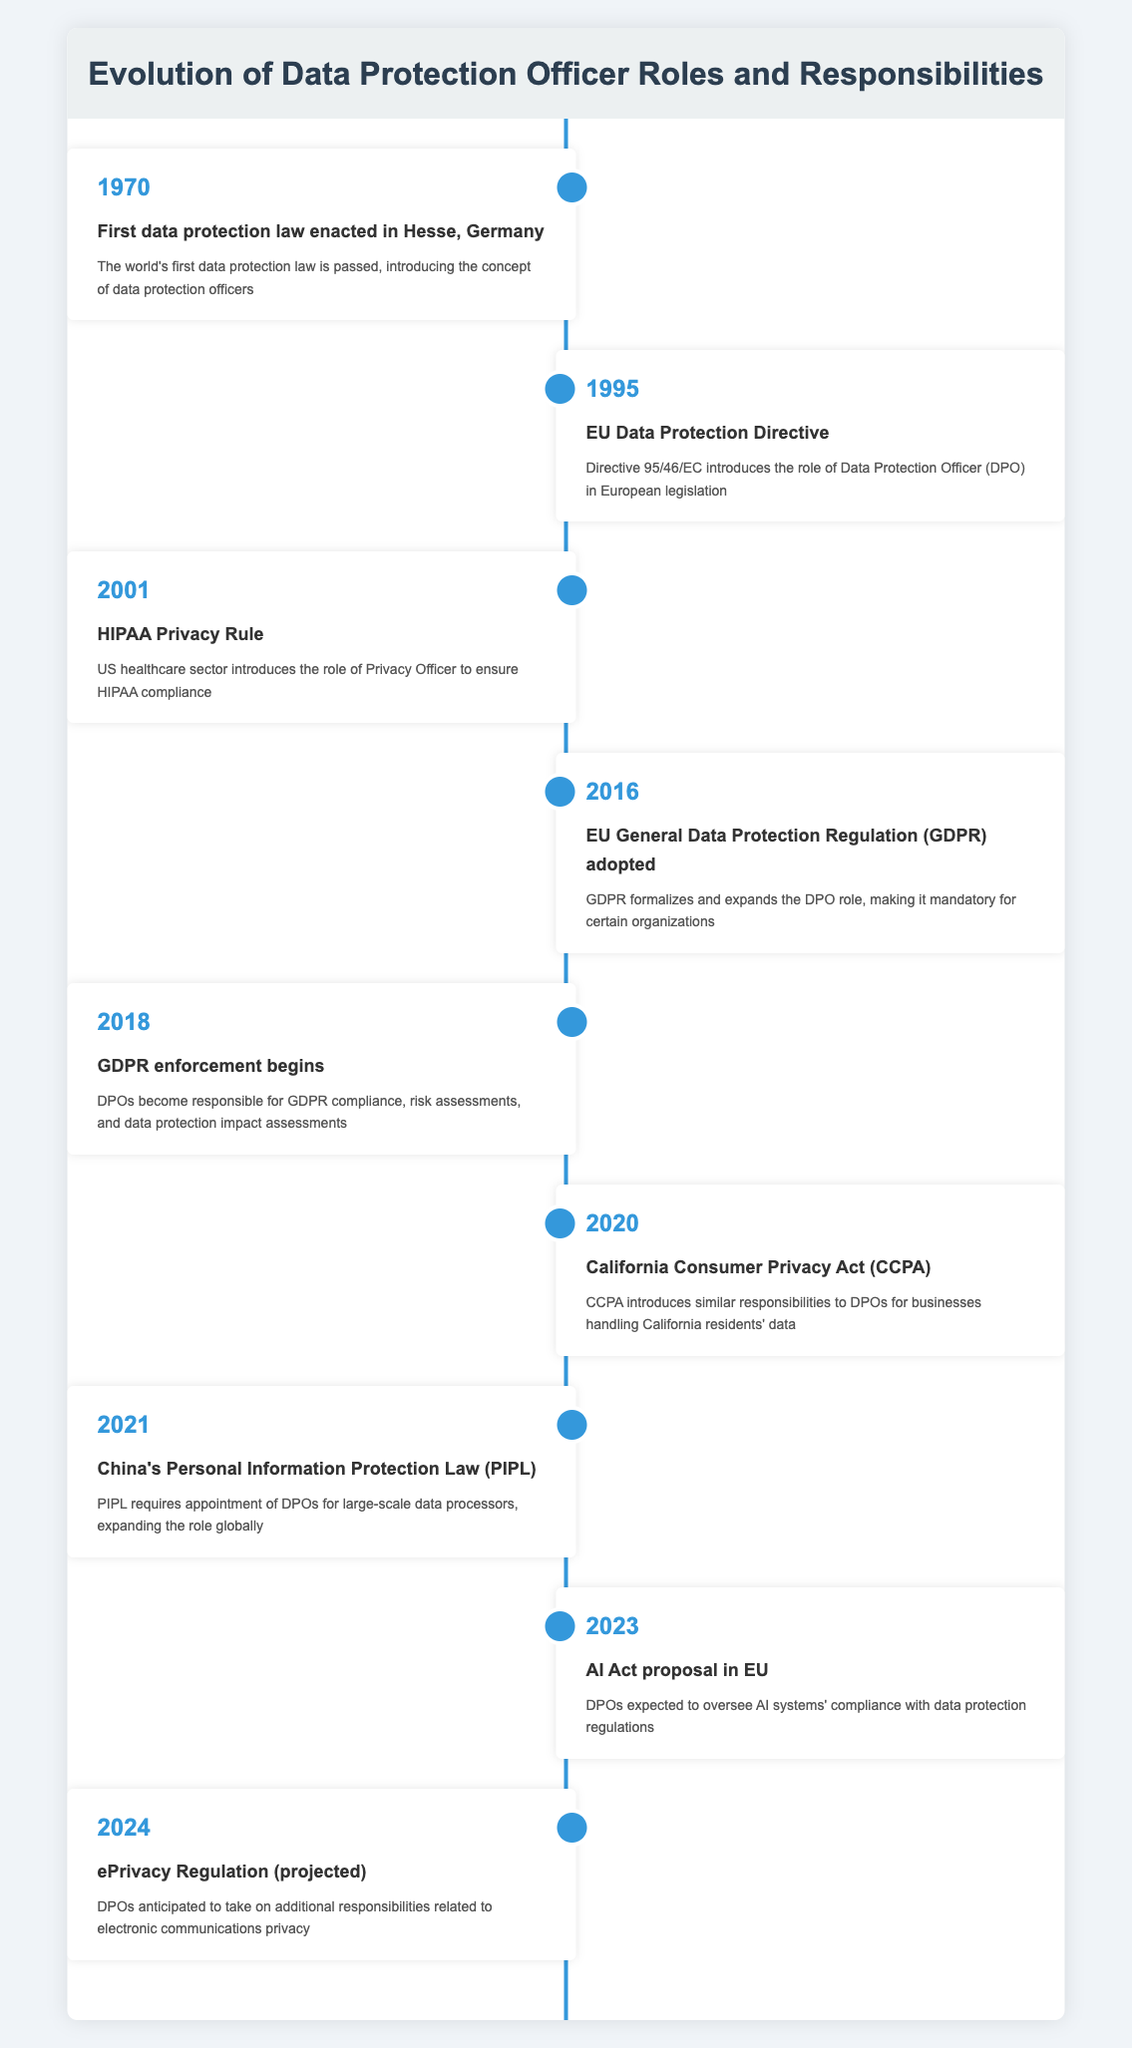What year was the first data protection law enacted? The table indicates that the first data protection law was enacted in the year 1970 in Hesse, Germany.
Answer: 1970 Which event introduced the role of Data Protection Officer in European legislation? According to the table, the event that introduced the role of Data Protection Officer (DPO) in European legislation is the EU Data Protection Directive in 1995.
Answer: EU Data Protection Directive How many years passed between the introduction of the EU Data Protection Directive and the enforcement of the GDPR? The EU Data Protection Directive was enacted in 1995 and GDPR enforcement began in 2018. To find the number of years passed: 2018 - 1995 = 23 years.
Answer: 23 years Did the HIPAA Privacy Rule introduce the role of Data Protection Officer? The table states that the HIPAA Privacy Rule in 2001 introduced the role of Privacy Officer, not specifically the Data Protection Officer. Therefore, the answer is no.
Answer: No In what year did China's Personal Information Protection Law require the appointment of DPOs? The table shows that China's Personal Information Protection Law (PIPL) required the appointment of DPOs in 2021.
Answer: 2021 What is the projected additional responsibility for DPOs associated with the ePrivacy Regulation? The table indicates that DPOs are anticipated to take on additional responsibilities related to electronic communications privacy with the projected ePrivacy Regulation in 2024.
Answer: Electronic communications privacy What significant role expansion occurred with the adoption of the GDPR? The table notes that with the adoption of the GDPR in 2016, the DPO role was formalized and expanded, making it mandatory for certain organizations. This indicates a significant role expansion.
Answer: Expanded DPO role How many events in the timeline specifically mention responsibilities related to data protection compliance? By reviewing the timeline, we can identify that there are three events: GDPR enforcement begins in 2018, CCPA in 2020, and PIPL in 2021, which specifically mention responsibilities related to data protection compliance. Thus, the count is three.
Answer: 3 events What was the first legislation that introduced data protection officers globally? The table indicates that the first data protection law enacted in Hesse, Germany in 1970 introduced the concept of data protection officers.
Answer: 1970 Data Protection Law in Hesse, Germany 